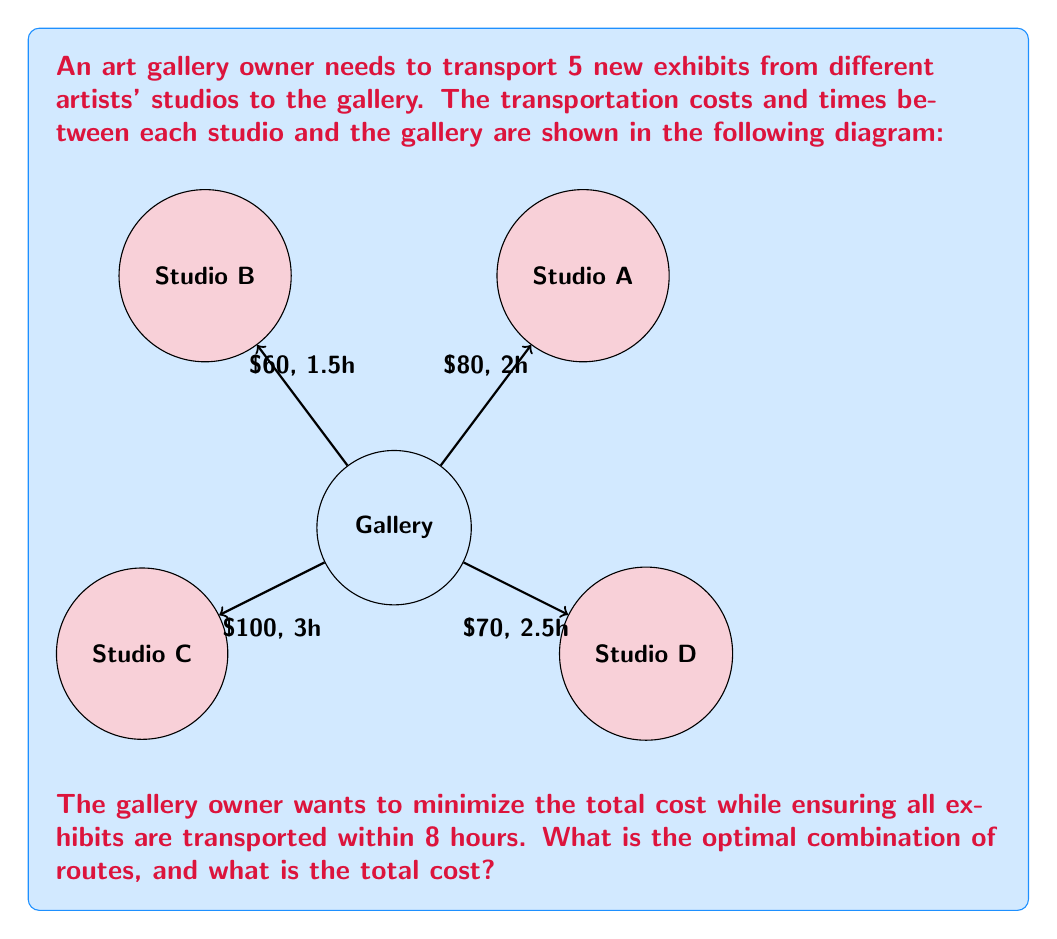Provide a solution to this math problem. To solve this problem, we'll use a combination of the Knapsack problem and Linear Programming concepts.

Step 1: Define variables
Let $x_i$ be a binary variable where:
$x_i = 1$ if studio i is selected, 0 otherwise
i = A, B, C, D

Step 2: Set up the objective function
Minimize: $Z = 80x_A + 60x_B + 100x_C + 70x_D$

Step 3: Set up the constraints
Time constraint: $2x_A + 1.5x_B + 3x_C + 2.5x_D \leq 8$
Number of exhibits: $x_A + x_B + x_C + x_D = 5$
Binary constraints: $x_i \in \{0,1\}$ for all i

Step 4: Solve the linear programming problem
We can solve this using the branch and bound method or a solver. The optimal solution is:
$x_A = 1, x_B = 1, x_C = 1, x_D = 1$

Step 5: Calculate the total cost and time
Total cost = $80 + 60 + 100 + 70 = $310
Total time = 2 + 1.5 + 3 + 2.5 = 8 hours

Therefore, the optimal combination is to use all four routes, transporting one exhibit from each studio.
Answer: Use all four routes; total cost $310 